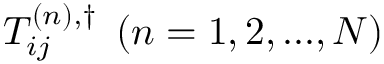<formula> <loc_0><loc_0><loc_500><loc_500>{ T _ { i j } ^ { \left ( n \right ) , \dag } } \, \left ( { n = 1 , 2 , \dots , N } \right )</formula> 